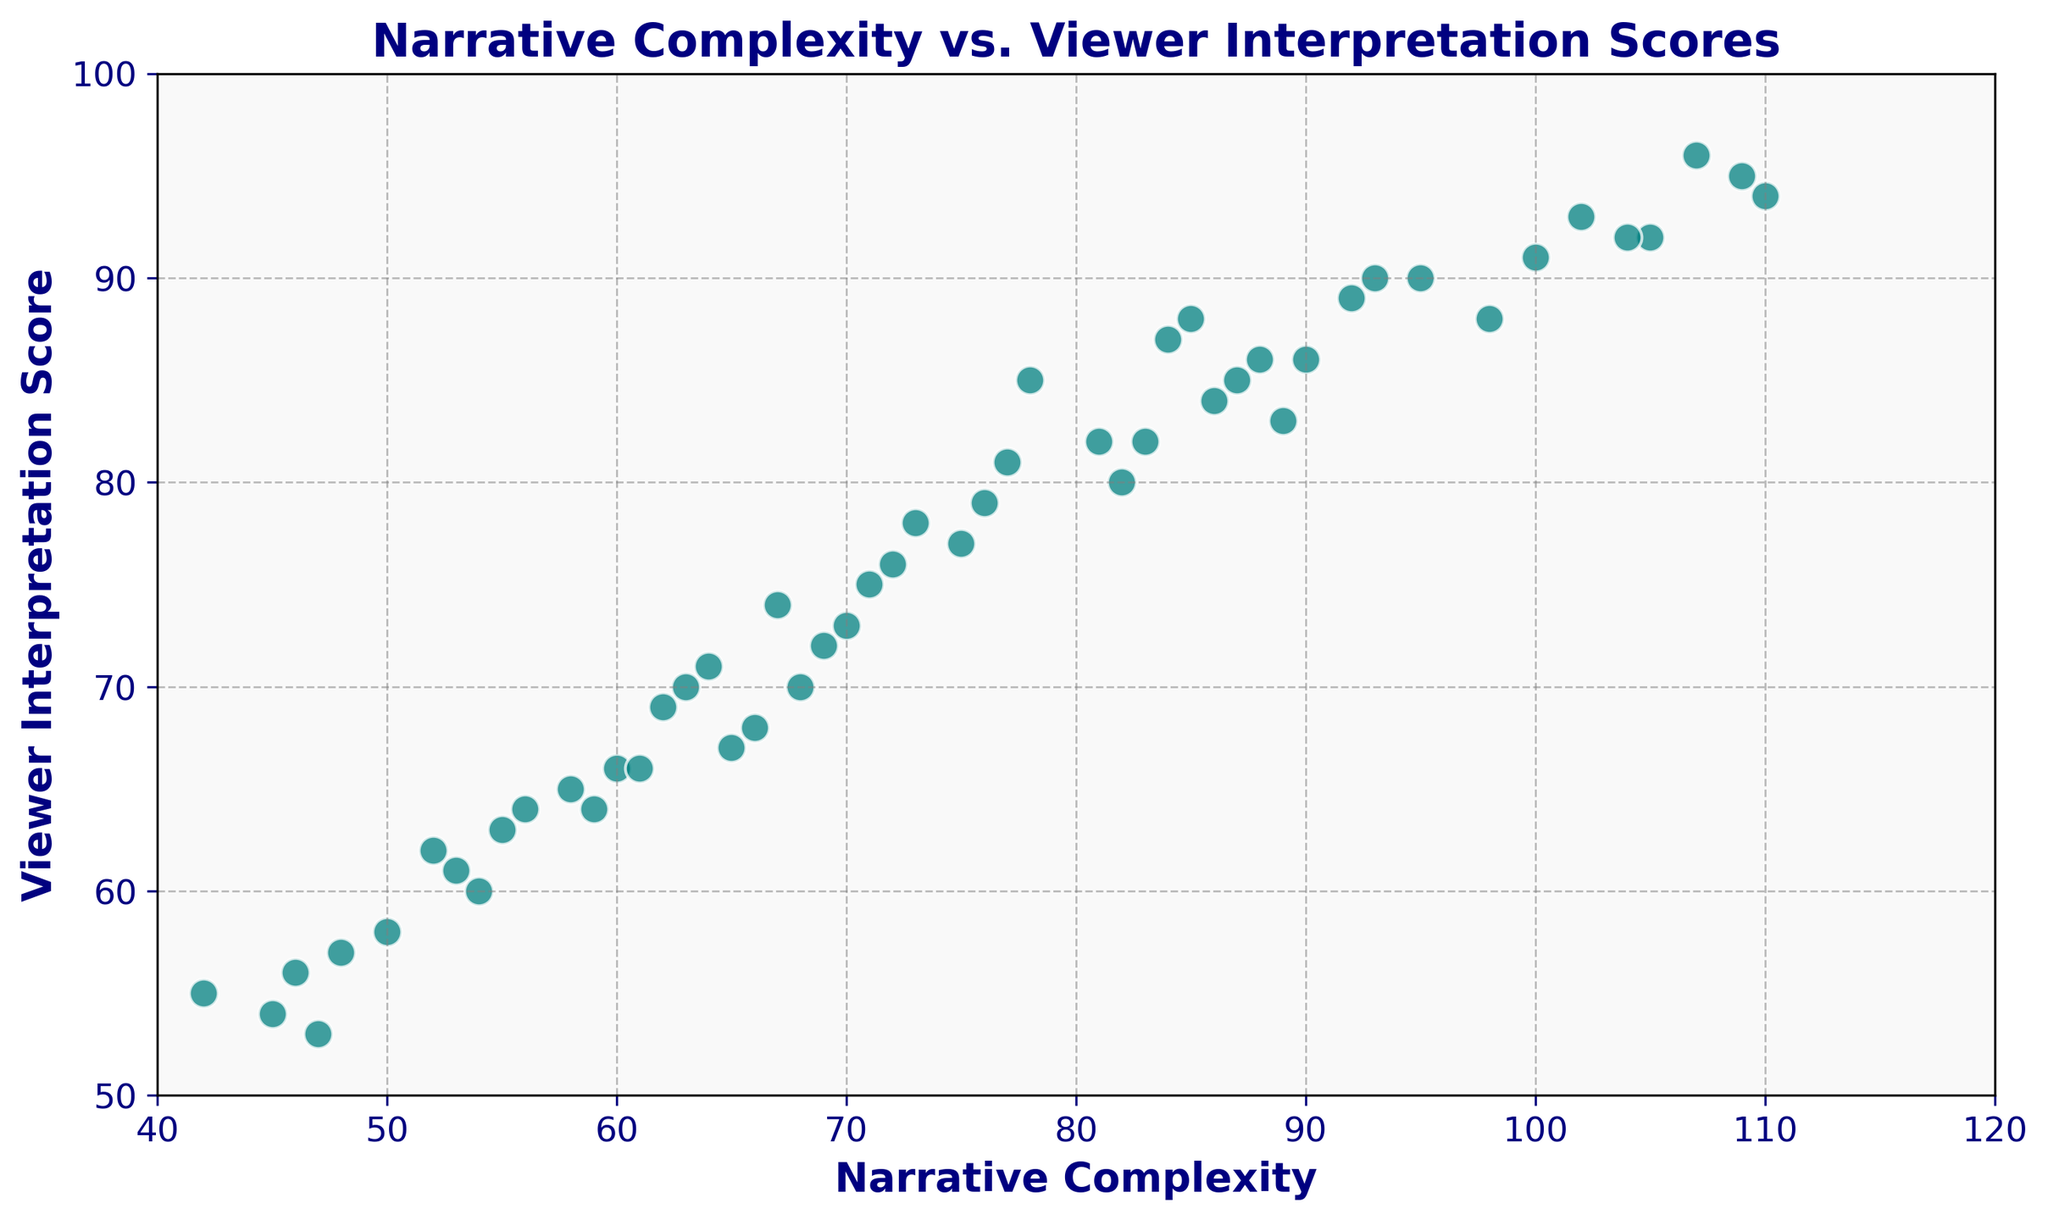What is the range of Viewer Interpretation Scores for artworks with Narrative Complexity below 60? To find the range, identify the maximum and minimum Viewer Interpretation Scores where Narrative Complexity is below 60. Data points: (54,60), (42,55), (48,57), (58,65), (52,62), (46,56), (53,61), (59,64), (45,54). Maximum: 65, Minimum: 54. Therefore, the range is 65 - 54 = 11.
Answer: 11 Which artwork has the highest Viewer Interpretation Score and what is its Narrative Complexity? Identify the data point with the highest Viewer Interpretation Score. The highest score is 96. The corresponding Narrative Complexity for this score is 107.
Answer: Narrative Complexity: 107 How many artworks have a Viewer Interpretation Score greater than 80? Count the points where Viewer Interpretation Score is greater than 80. Data points: (78,85), (109,95), (85,88), (95,90), (105,92), (89,83), (81,82), (100,91), (90,86), (84,87), (92,89), (102,93), (86,84), (107,96), (87,85), (104,92), (88,86), (93,90). Total: 18.
Answer: 18 For artworks with Narrative Complexity between 70 and 80, what is the average Viewer Interpretation Score? Filter points between 70 and 80: (71,75), (73,78), (75,77), (72,76), (77,81), (76,79). Sum of Viewer Interpretation Scores: 75 + 78 + 77 + 76 + 81 + 79 = 466. Number of points: 6. Average: 466/6.
Answer: 77.67 What color represents the scatter plot markers, and what size are they? Visually locate scatter plot markers and refer to their color and size in the plot description. The markers are teal and of size 100.
Answer: Teal, 100 What is the general trend displayed in the scatter plot between Narrative Complexity and Viewer Interpretation Scores? Look at the spread of data points. Most points plot a trend where higher Narrative Complexity corresponds with higher Viewer Interpretation Scores. The relation seems positively correlated.
Answer: Positive correlation What is the Viewer Interpretation Score for an artwork with a Narrative Complexity of 64? Locate the data point where Narrative Complexity is 64. The corresponding Viewer Interpretation Score shown in the plot is 71.
Answer: 71 Compare the Viewer Interpretation Scores for artworks with Narrative Complexities of 66 and 67. Which is higher, and by how much? Identify points: (66,68) and (67,74). Compare scores 68 and 74. 74 is higher by 74 - 68 = 6.
Answer: 74, by 6 